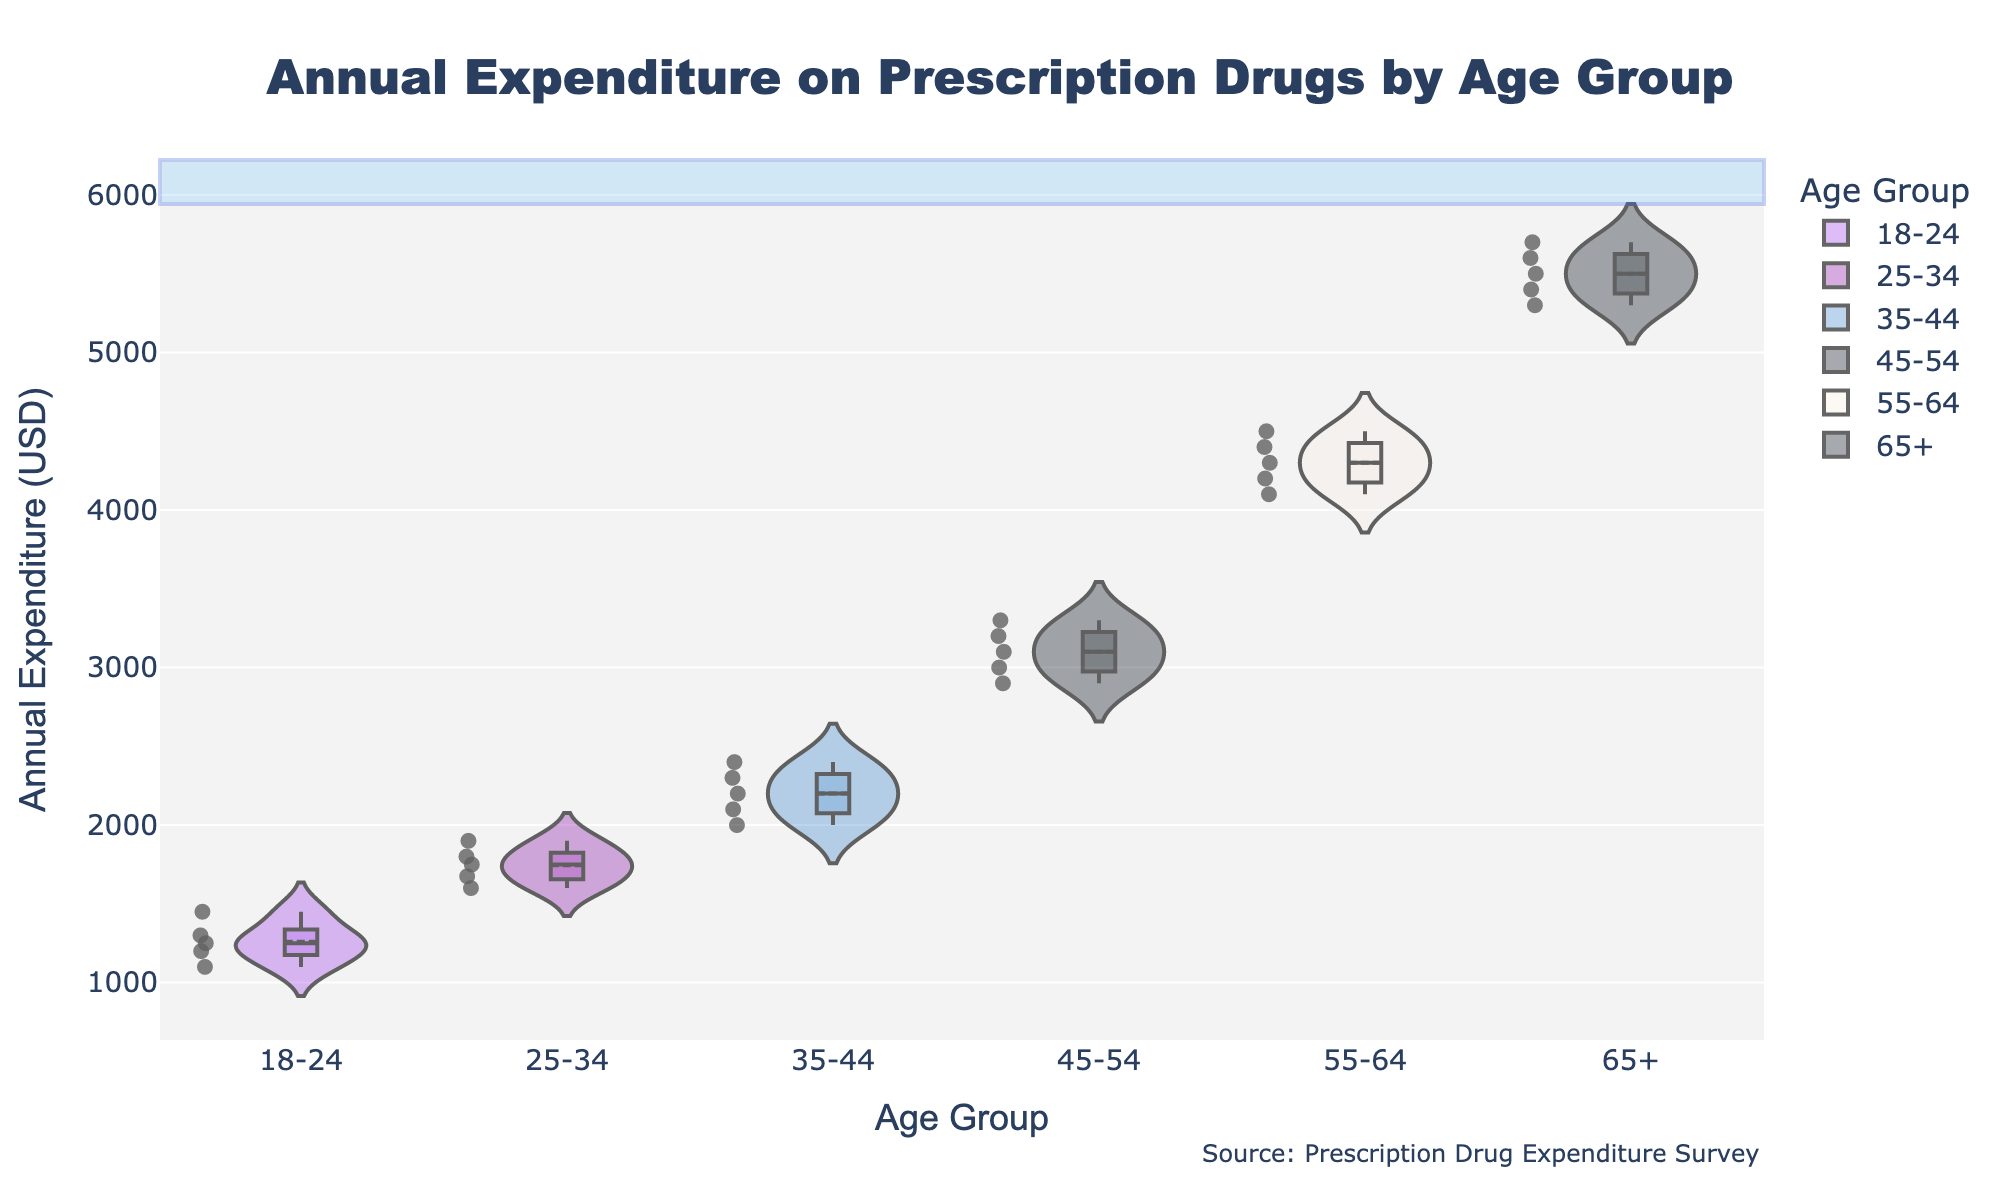What is the title of the figure? The title is displayed prominently at the top of the figure. It reads "Annual Expenditure on Prescription Drugs by Age Group."
Answer: Annual Expenditure on Prescription Drugs by Age Group Which age group has the highest median annual expenditure? The median is shown by a horizontal line within each violin plot. The age group "65+" has the highest median line among all age groups.
Answer: 65+ What is the approximate median annual expenditure for the 35-44 age group? The median is the horizontal line inside the violin plot. For the 35-44 age group, it appears near $2200.
Answer: $2200 How many data points are there for the 18-24 age group? Each dot within the violin plot represents a data point. By counting them, you can determine there are 5 data points for the 18-24 age group.
Answer: 5 What is the range of annual expenditure for the 55-64 age group? The range is the difference between the highest and lowest points in the violin plot. For 55-64, the expenditure ranges from approximately $4100 to $4500.
Answer: $400 Does the 25-34 age group spend more than the 45-54 age group on average? Comparing the centers of the violin plots, which represent the means, the 45-54 age group has a higher mean expenditure than the 25-34 group.
Answer: No Which age group has the widest distribution of expenditure? The width of the violin plot indicates the distribution spread. The "65+" age group has the widest plot, indicating the widest distribution.
Answer: 65+ By how much does the maximum annual expenditure for the 45-54 age group exceed that for the 35-44 age group? The highest points for the 45-54 and 35-44 age groups are around $3300 and $2400, respectively. The difference is $3300 - $2400.
Answer: $900 What is the mean annual expenditure for the 25-34 age group? The mean is indicated by a dashed line within each violin plot. For the 25-34 age group, the mean appears close to $1745.
Answer: $1745 Between which two consecutive age groups is the increase in median annual expenditure the largest? Comparing the median lines, the largest increase in median expenditure occurs between the "55-64" and "65+" age groups.
Answer: 55-64 to 65+ 